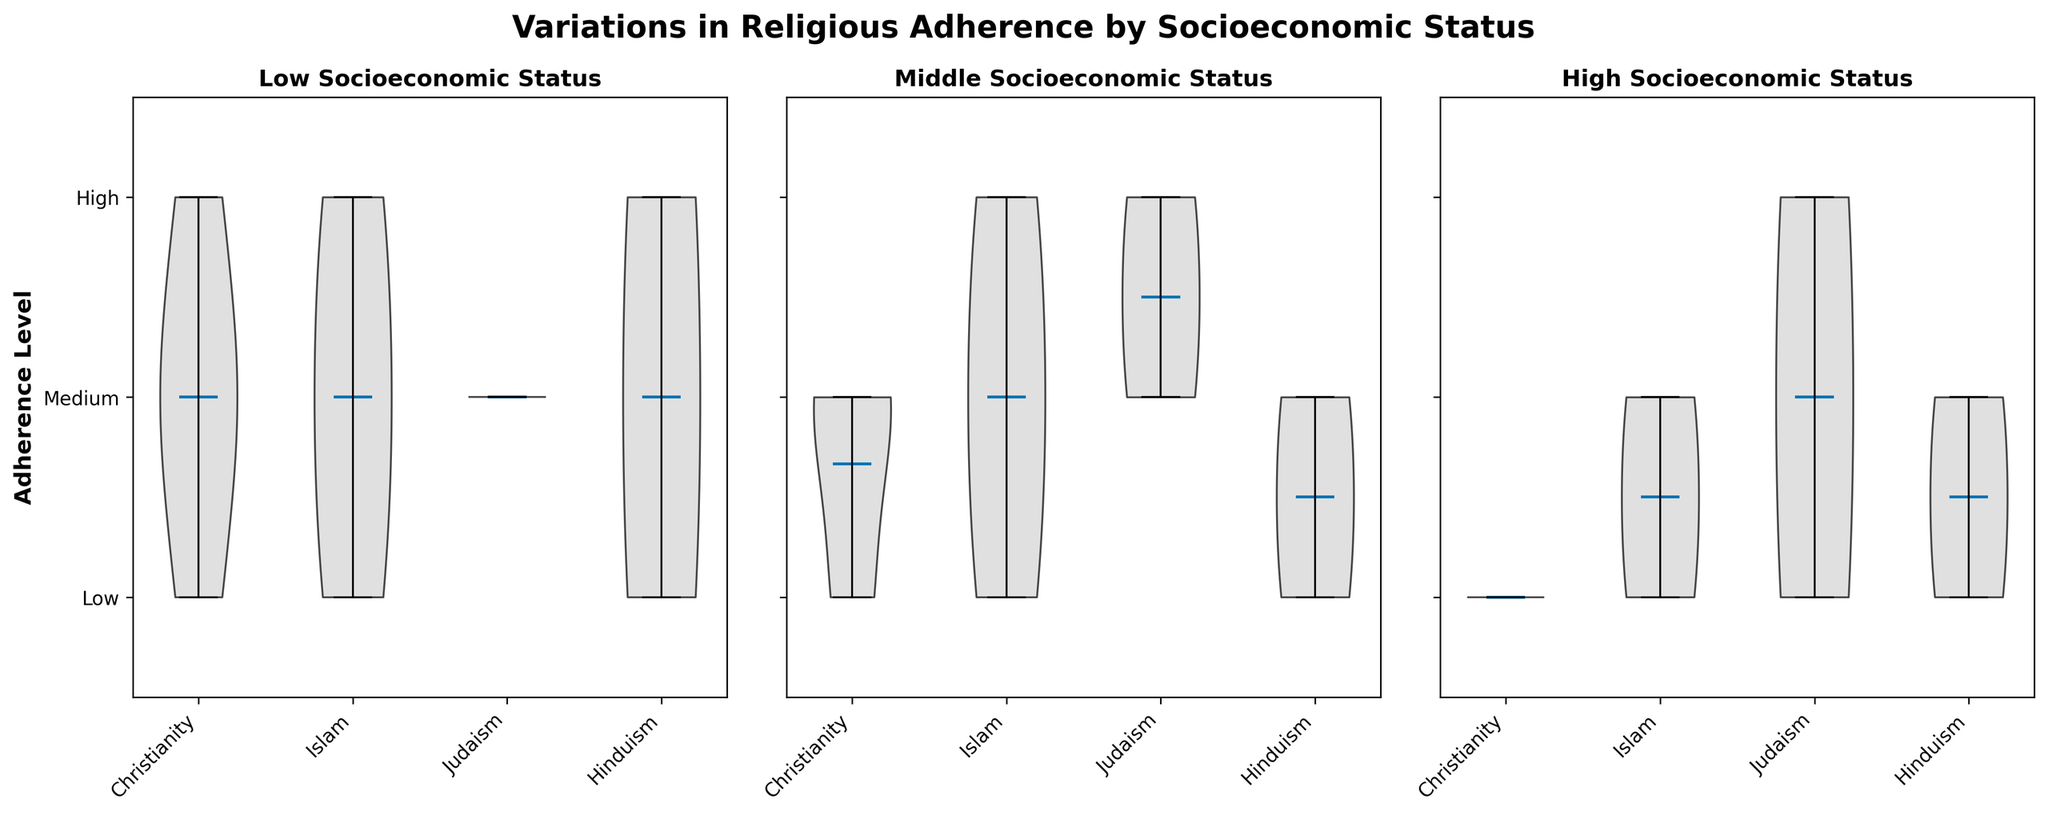What is the title of the figure? The title of the figure is shown at the top in bold font.
Answer: Variations in Religious Adherence by Socioeconomic Status Which socioeconomic status group has the highest adherence level in Christianity? Look at the subplots for each socioeconomic status and compare the position of the violins for Christianity. The highest violin position indicates the highest adherence level.
Answer: Low How does adherence to Islam vary by socioeconomic status? Look at the violins for Islam in each subplot (Low, Middle, High). Note the distribution of the adherence levels within each status group.
Answer: High adherence in Low; Medium adherence in Middle; Low adherence in High What adherence levels are present for Judaism in the Middle socioeconomic status group? Look at the plot for Middle socioeconomic status and check the distribution of the violin for Judaism.
Answer: High and Medium Between Hinduism and Judaism, which religion has a higher adherence level in the High socioeconomic status group? Compare the violin plots of Hinduism and Judaism in the High socioeconomic status group.
Answer: Judaism Which religion shows the most variation in adherence levels within the Low socioeconomic status group? Look at the width and spread of the violins in the Low socioeconomic status group subplot. The violin with the widest spread indicates the most variation.
Answer: Christianity For which socioeconomic status does Christianity have the lowest adherence level? Look at the violins for Christianity across Low, Middle, and High socioeconomic status groups and identify where the adherence level is the lowest.
Answer: High Is there any religion that shows a 'High' adherence level across all socioeconomic statuses? Check the violin plots for each religion in all three socioeconomic statuses and see if any religion consistently has a 'High' adherence level.
Answer: No What is the most common adherence level for Hinduism in the Middle socioeconomic status group? Observe the violin plot for Hinduism in the Middle socioeconomic status subplot. The adherence level corresponding to the most central or bulging part of the violin indicates the most common adherence level.
Answer: Medium 